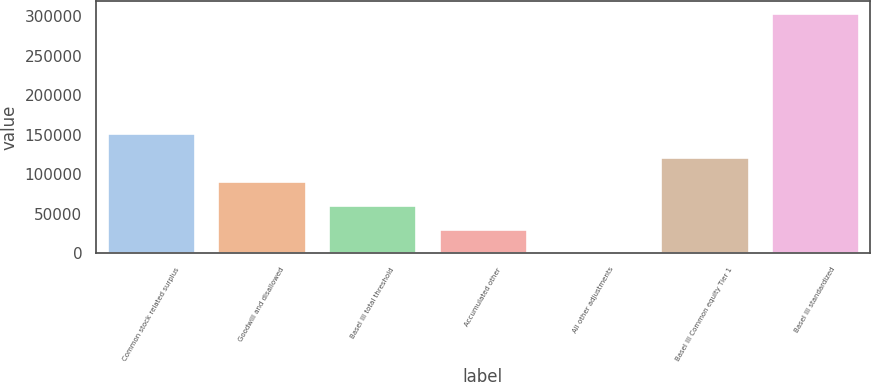Convert chart to OTSL. <chart><loc_0><loc_0><loc_500><loc_500><bar_chart><fcel>Common stock related surplus<fcel>Goodwill and disallowed<fcel>Basel III total threshold<fcel>Accumulated other<fcel>All other adjustments<fcel>Basel III Common equity Tier 1<fcel>Basel III standardized<nl><fcel>151944<fcel>91239.5<fcel>60887<fcel>30534.5<fcel>182<fcel>121592<fcel>303707<nl></chart> 